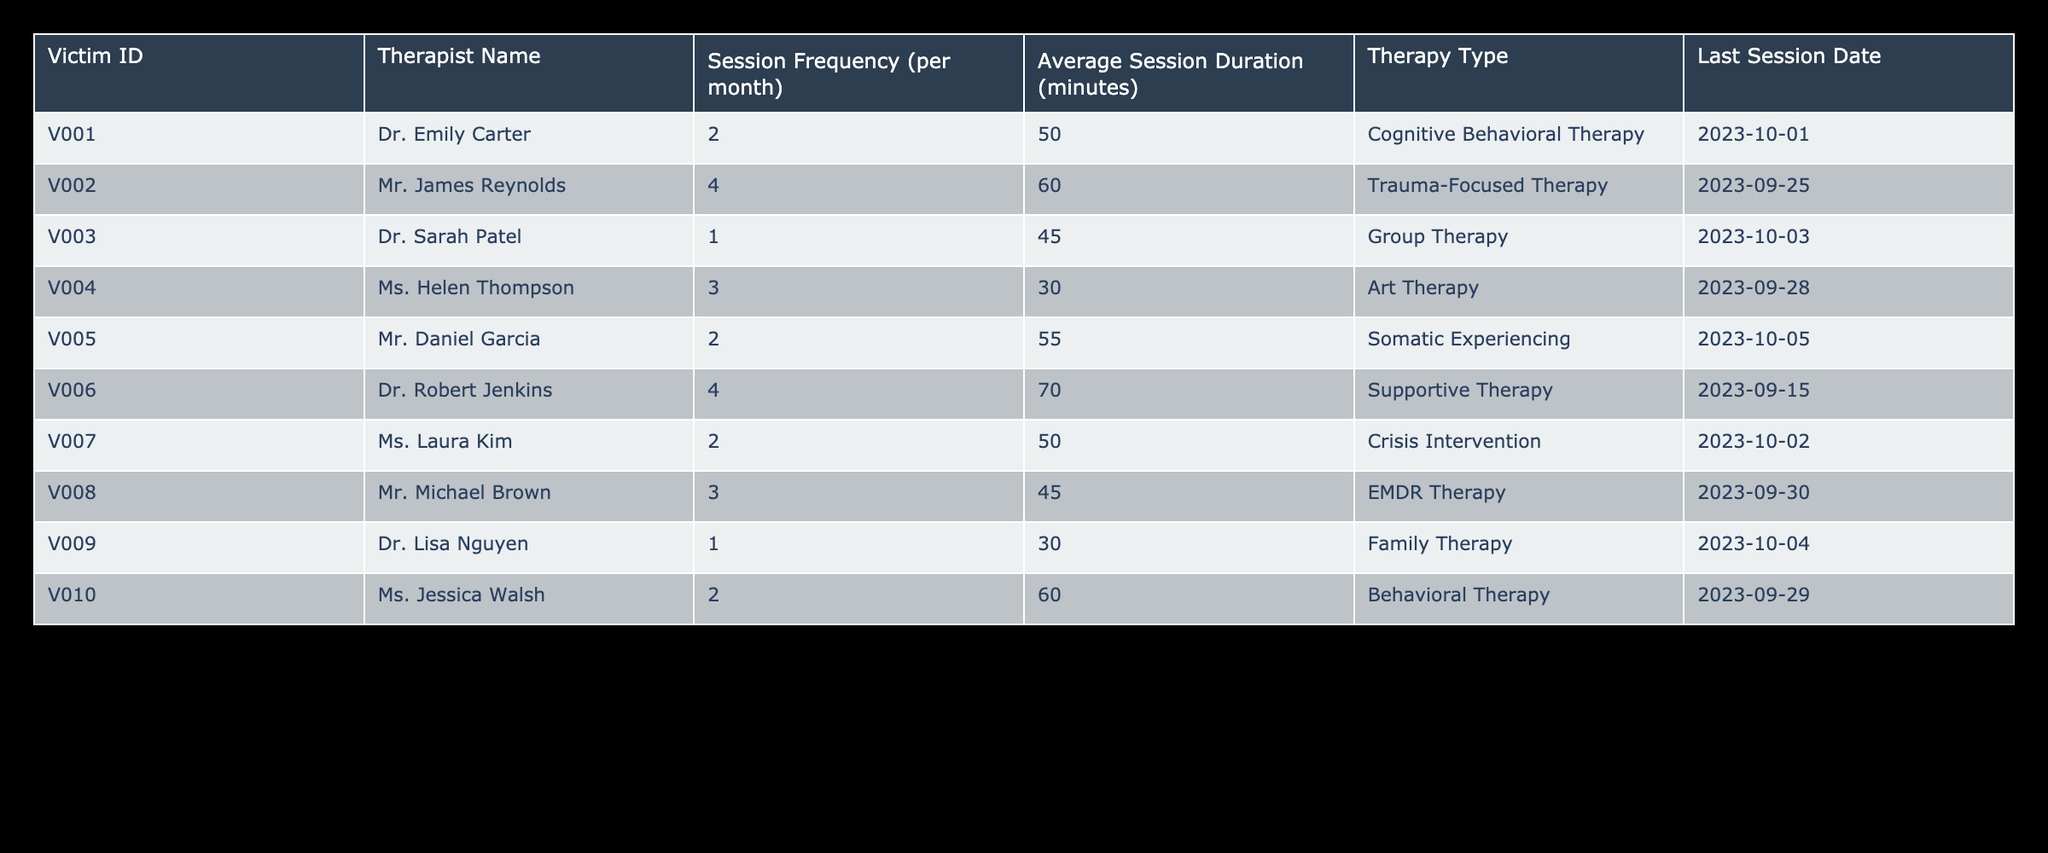What is the average session duration across all victims? To find the average session duration, we sum the session durations (50 + 60 + 45 + 30 + 55 + 70 + 50 + 45 + 30 + 60 =  495) and divide by the number of victims (10). The average is 495/10 = 49.5 minutes.
Answer: 49.5 minutes How many victims have a therapy session frequency of 4 per month? By looking at the table, we can count the instances of a session frequency of 4 per month. Reviewing the data, we see that victims V002 and V006 have a frequency of 4, giving us a total of 2 victims.
Answer: 2 Is there any victim who has a session duration of 30 minutes? By scanning the table for session durations, we find that victim V009 has a session duration of 30 minutes. Since we found this information, the answer is yes.
Answer: Yes Which therapy type has the longest average session duration? Looking at the average session durations for each therapy type: Cognitive Behavioral Therapy (50), Trauma-Focused Therapy (60), Group Therapy (45), Art Therapy (30), Somatic Experiencing (55), Supportive Therapy (70), Crisis Intervention (50), EMDR Therapy (45), Family Therapy (30), and Behavioral Therapy (60). The highest value is 70, associated with Supportive Therapy.
Answer: Supportive Therapy What is the total number of therapy sessions scheduled for all victims per month? We can calculate the total by summing the session frequencies for each victim (2 + 4 + 1 + 3 + 2 + 4 + 2 + 3 + 1 + 2 = 24). Therefore, the total number of therapy sessions scheduled per month is 24.
Answer: 24 